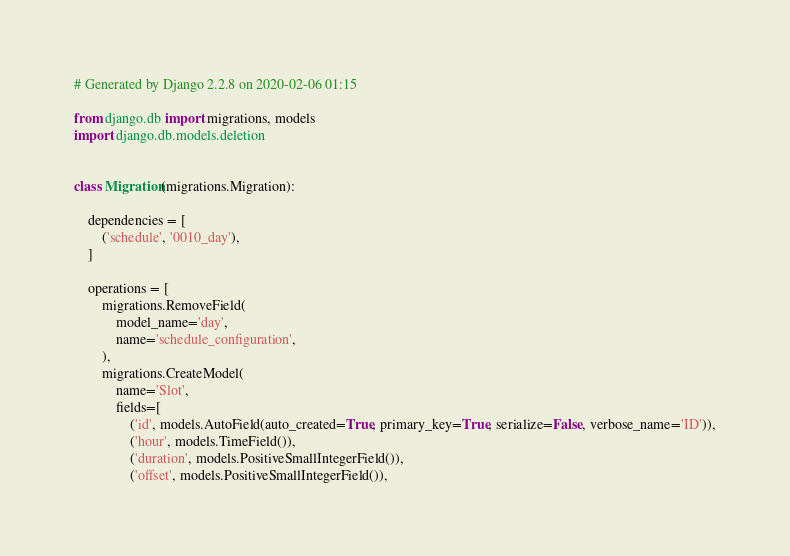<code> <loc_0><loc_0><loc_500><loc_500><_Python_># Generated by Django 2.2.8 on 2020-02-06 01:15

from django.db import migrations, models
import django.db.models.deletion


class Migration(migrations.Migration):

    dependencies = [
        ('schedule', '0010_day'),
    ]

    operations = [
        migrations.RemoveField(
            model_name='day',
            name='schedule_configuration',
        ),
        migrations.CreateModel(
            name='Slot',
            fields=[
                ('id', models.AutoField(auto_created=True, primary_key=True, serialize=False, verbose_name='ID')),
                ('hour', models.TimeField()),
                ('duration', models.PositiveSmallIntegerField()),
                ('offset', models.PositiveSmallIntegerField()),</code> 